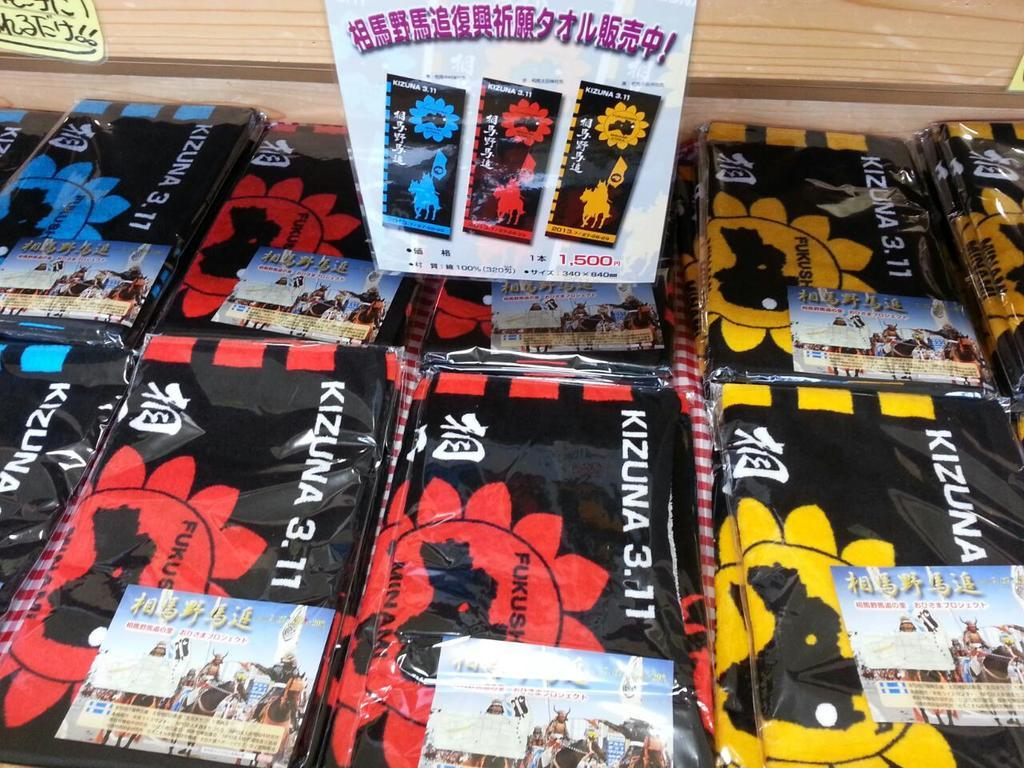What colors are the covers in the foreground of the image? The covers in the foreground of the image are in blue, yellow, red, and black colors. What might these covers be used for? These covers might be book covers. Can you describe the wooden object at the top of the image? Unfortunately, there is no information about the wooden object at the top of the image in the provided facts. How does the cactus in the image affect the temper of the person reading the book? There is no cactus present in the image, so it cannot affect the temper of the person reading the book. 